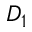<formula> <loc_0><loc_0><loc_500><loc_500>D _ { 1 }</formula> 